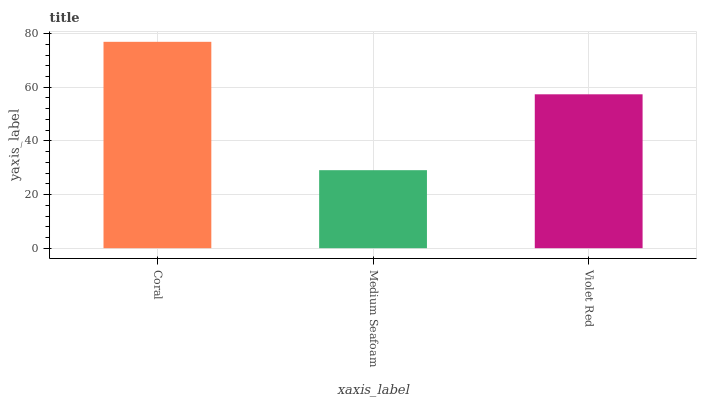Is Medium Seafoam the minimum?
Answer yes or no. Yes. Is Coral the maximum?
Answer yes or no. Yes. Is Violet Red the minimum?
Answer yes or no. No. Is Violet Red the maximum?
Answer yes or no. No. Is Violet Red greater than Medium Seafoam?
Answer yes or no. Yes. Is Medium Seafoam less than Violet Red?
Answer yes or no. Yes. Is Medium Seafoam greater than Violet Red?
Answer yes or no. No. Is Violet Red less than Medium Seafoam?
Answer yes or no. No. Is Violet Red the high median?
Answer yes or no. Yes. Is Violet Red the low median?
Answer yes or no. Yes. Is Coral the high median?
Answer yes or no. No. Is Medium Seafoam the low median?
Answer yes or no. No. 